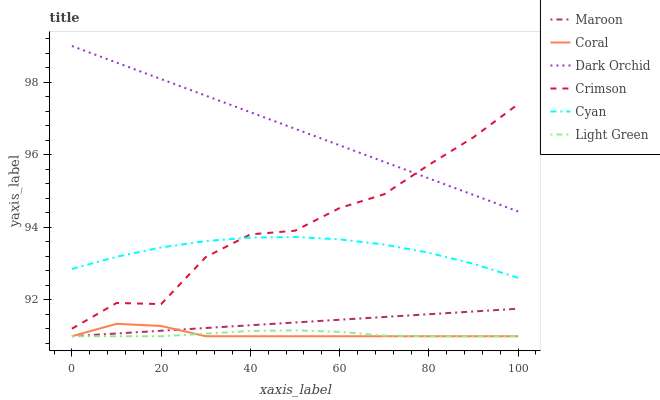Does Light Green have the minimum area under the curve?
Answer yes or no. Yes. Does Dark Orchid have the maximum area under the curve?
Answer yes or no. Yes. Does Maroon have the minimum area under the curve?
Answer yes or no. No. Does Maroon have the maximum area under the curve?
Answer yes or no. No. Is Dark Orchid the smoothest?
Answer yes or no. Yes. Is Crimson the roughest?
Answer yes or no. Yes. Is Maroon the smoothest?
Answer yes or no. No. Is Maroon the roughest?
Answer yes or no. No. Does Coral have the lowest value?
Answer yes or no. Yes. Does Dark Orchid have the lowest value?
Answer yes or no. No. Does Dark Orchid have the highest value?
Answer yes or no. Yes. Does Maroon have the highest value?
Answer yes or no. No. Is Coral less than Dark Orchid?
Answer yes or no. Yes. Is Cyan greater than Maroon?
Answer yes or no. Yes. Does Dark Orchid intersect Crimson?
Answer yes or no. Yes. Is Dark Orchid less than Crimson?
Answer yes or no. No. Is Dark Orchid greater than Crimson?
Answer yes or no. No. Does Coral intersect Dark Orchid?
Answer yes or no. No. 